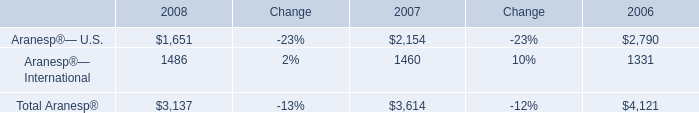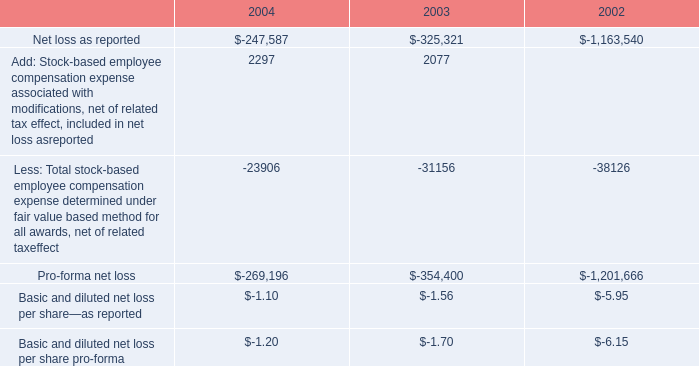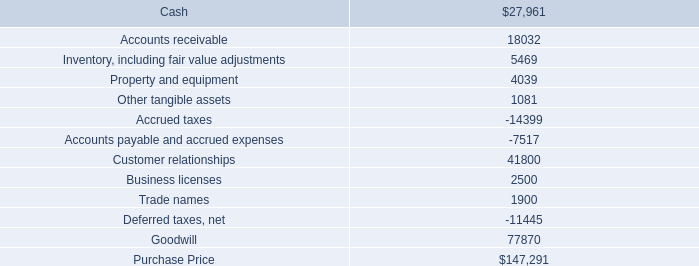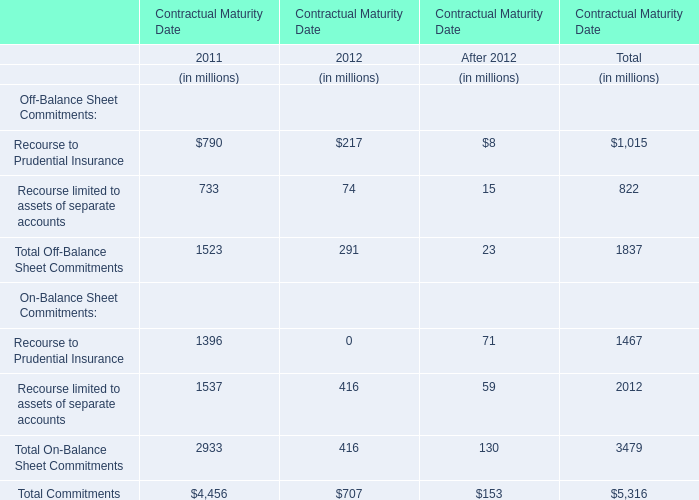For Contractual Maturity Date the year where Total Off-Balance Sheet Commitments is lower,what is the Total On-Balance Sheet Commitments? (in million) 
Answer: 416. 